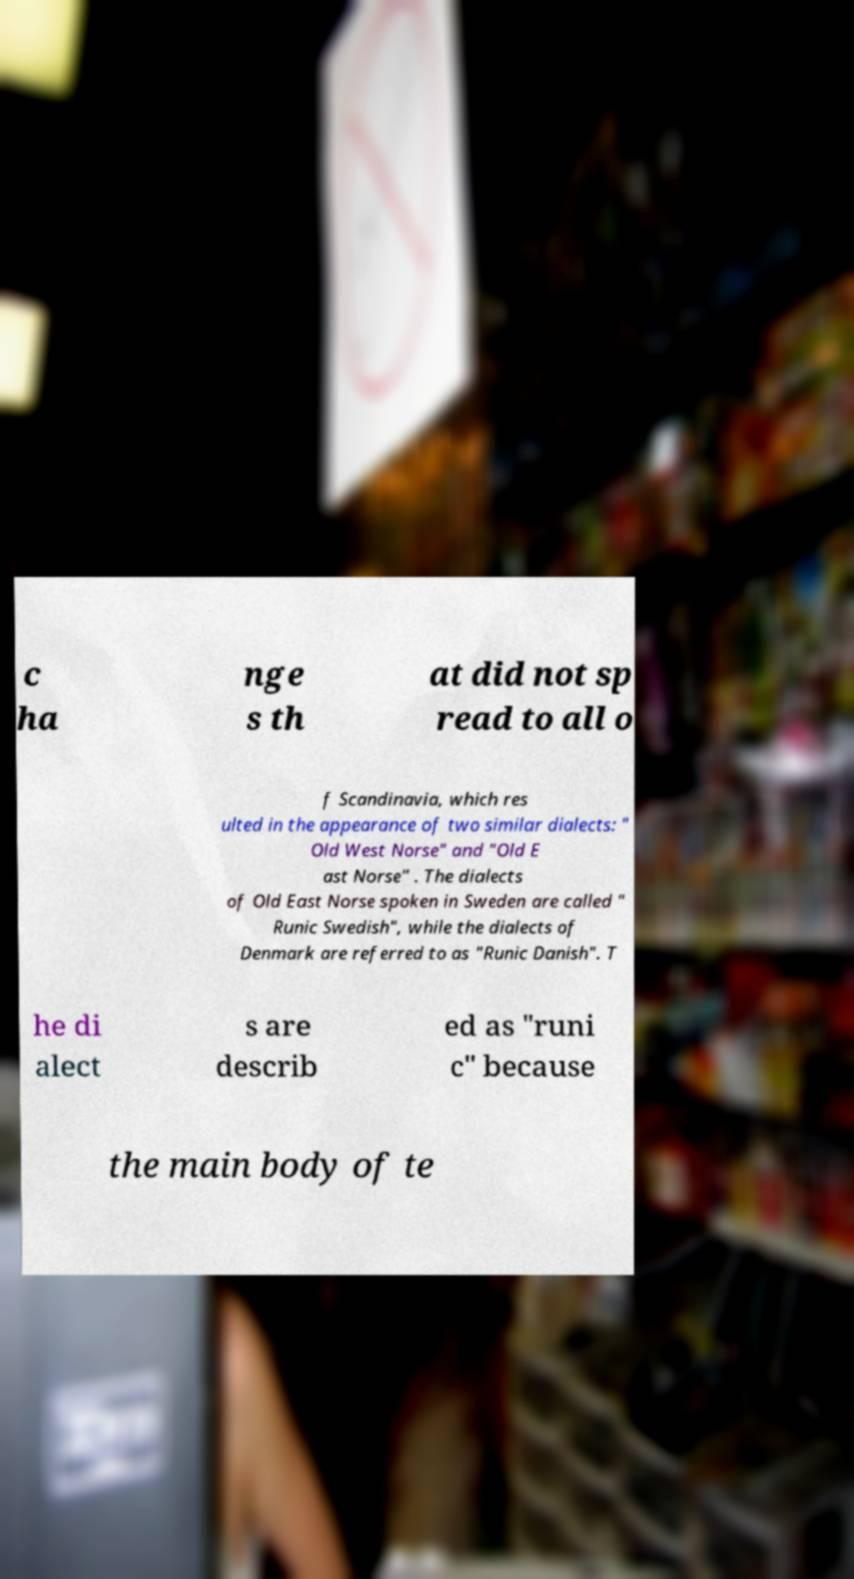Could you extract and type out the text from this image? c ha nge s th at did not sp read to all o f Scandinavia, which res ulted in the appearance of two similar dialects: " Old West Norse" and "Old E ast Norse" . The dialects of Old East Norse spoken in Sweden are called " Runic Swedish", while the dialects of Denmark are referred to as "Runic Danish". T he di alect s are describ ed as "runi c" because the main body of te 